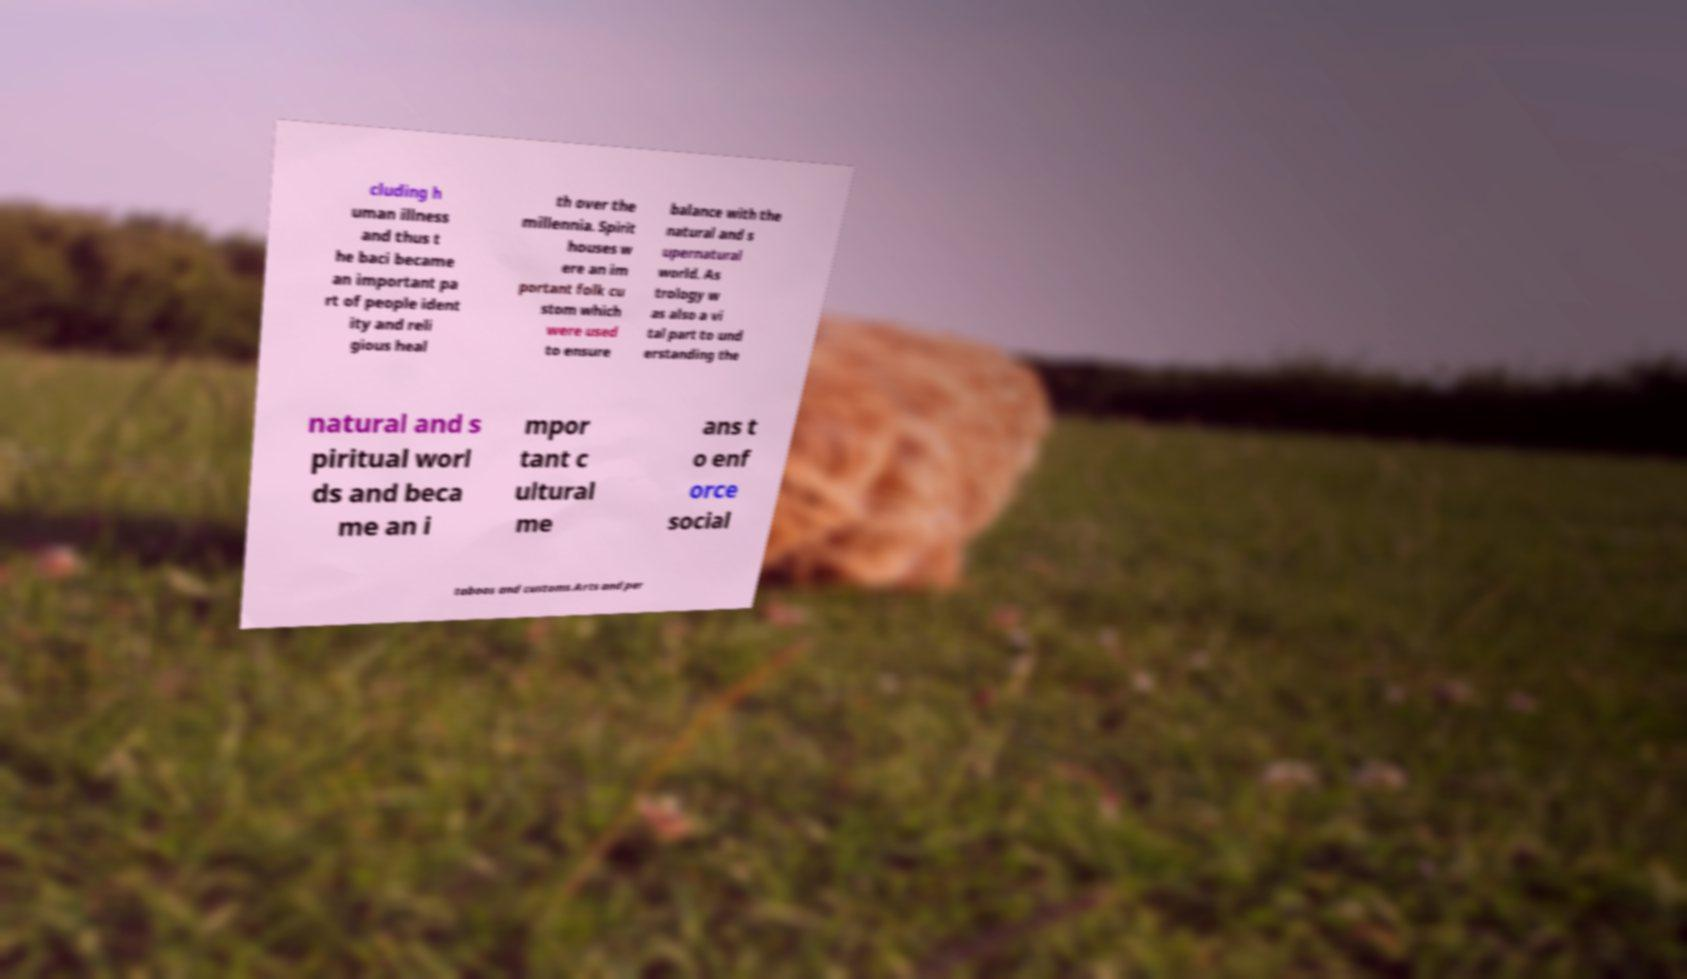Could you extract and type out the text from this image? cluding h uman illness and thus t he baci became an important pa rt of people ident ity and reli gious heal th over the millennia. Spirit houses w ere an im portant folk cu stom which were used to ensure balance with the natural and s upernatural world. As trology w as also a vi tal part to und erstanding the natural and s piritual worl ds and beca me an i mpor tant c ultural me ans t o enf orce social taboos and customs.Arts and per 